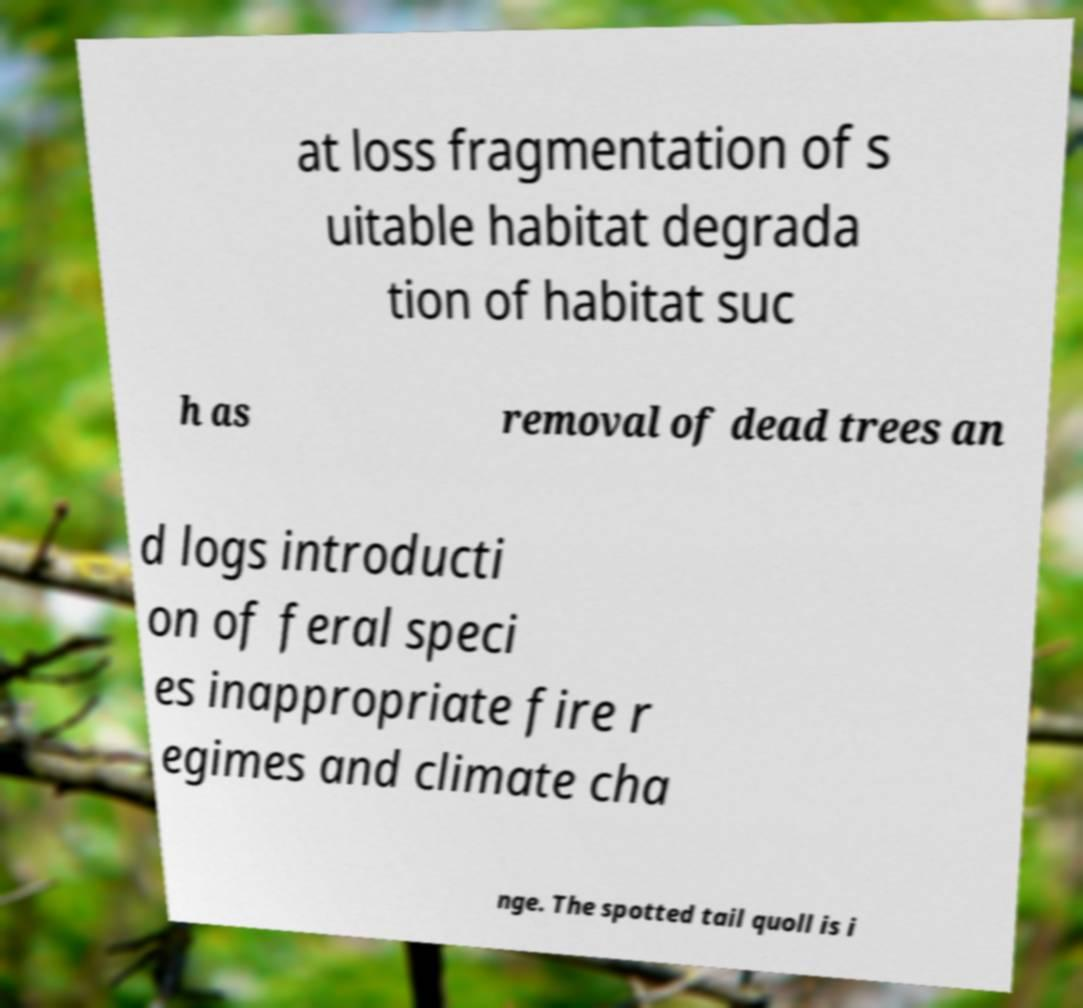What messages or text are displayed in this image? I need them in a readable, typed format. at loss fragmentation of s uitable habitat degrada tion of habitat suc h as removal of dead trees an d logs introducti on of feral speci es inappropriate fire r egimes and climate cha nge. The spotted tail quoll is i 